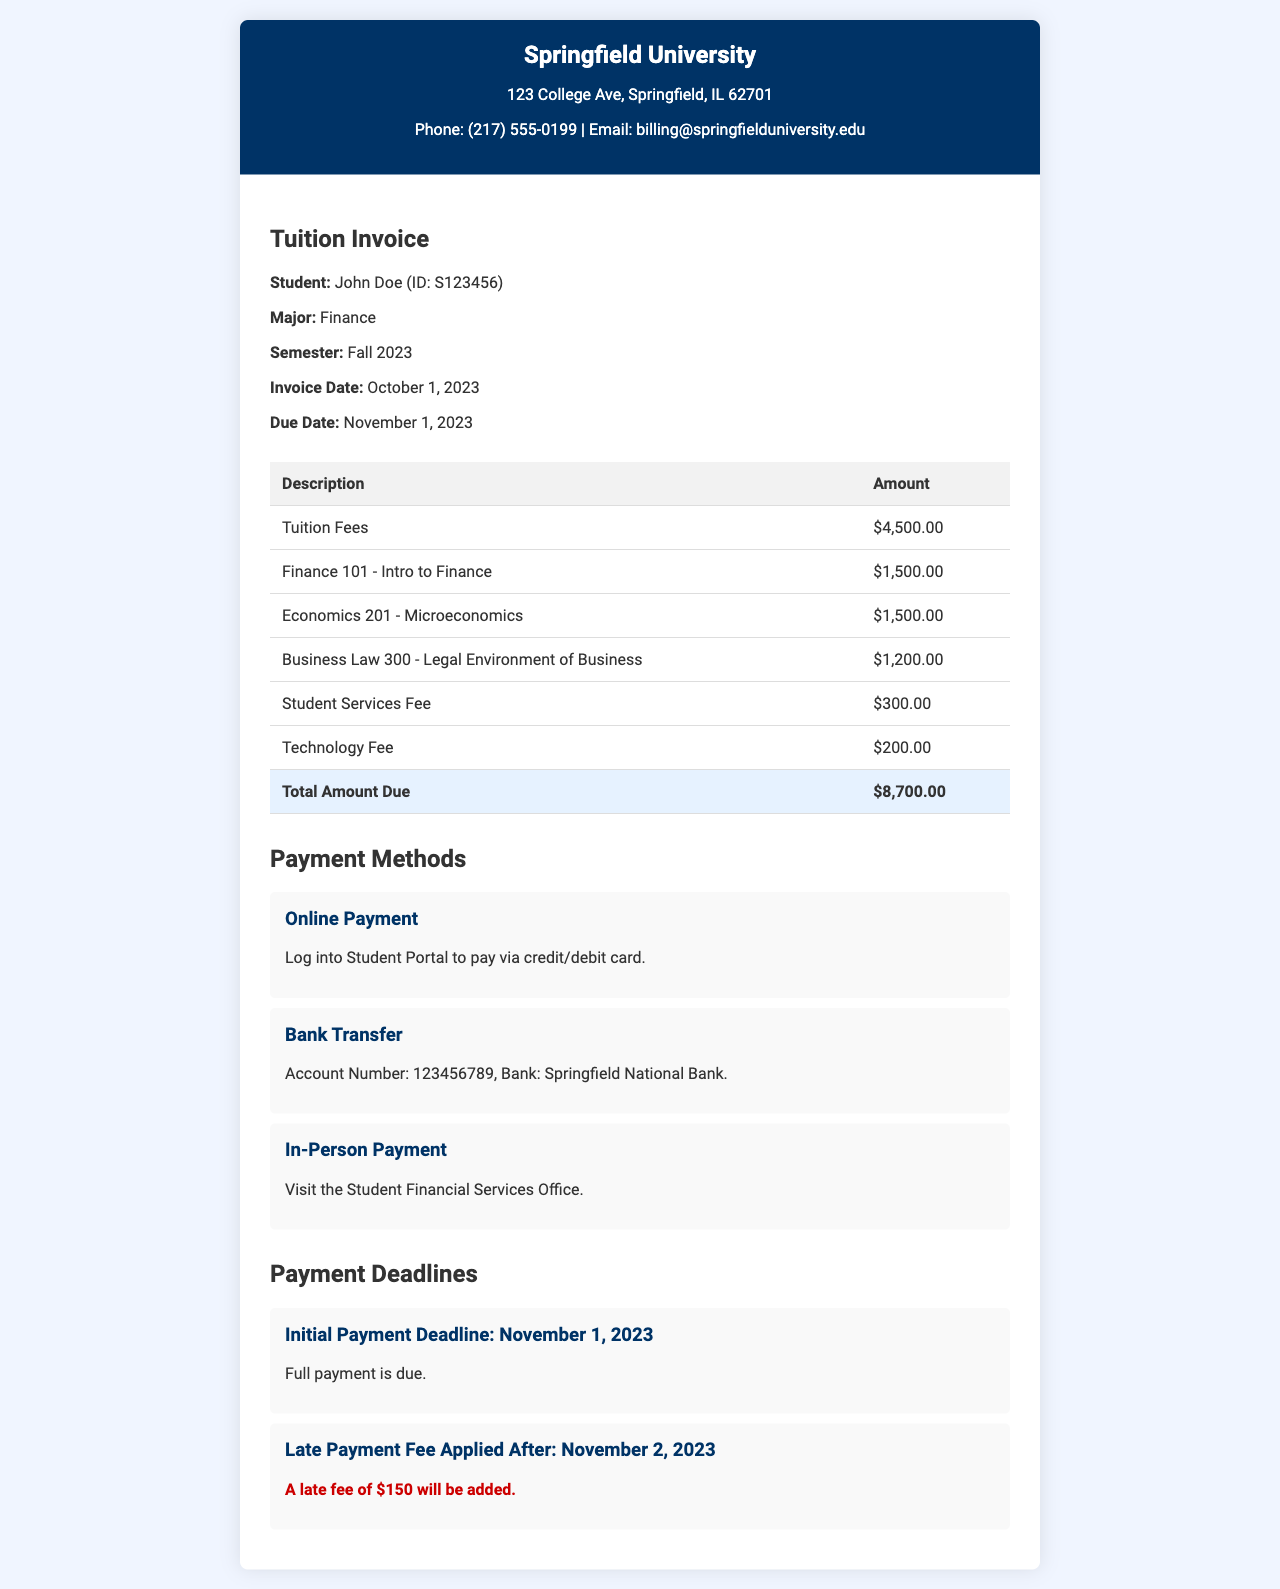What is the student's name? The student's name is listed prominently in the invoice under student information.
Answer: John Doe What is the total amount due? The total amount due is summarized at the bottom of the itemized charges table.
Answer: $8,700.00 What is the due date for the payment? The due date is clearly stated in the student information section of the invoice.
Answer: November 1, 2023 Which course has a fee of $1,500.00? Multiple courses have this fee, but the invoice clearly lists them separately.
Answer: Finance 101 - Intro to Finance, Economics 201 - Microeconomics What late fee applies after the payment deadline? The invoice specifies the consequence of not paying on time in the payment deadlines section.
Answer: $150 How can payments be made online? The invoice outlines the method of online payment in the payment methods section.
Answer: Log into Student Portal to pay via credit/debit card When is the late payment fee applied? The invoice provides specific details regarding when the late fee starts in the payment deadlines section.
Answer: November 2, 2023 What is the account number for bank transfer? The invoice lists this information under the payment methods section.
Answer: 123456789 